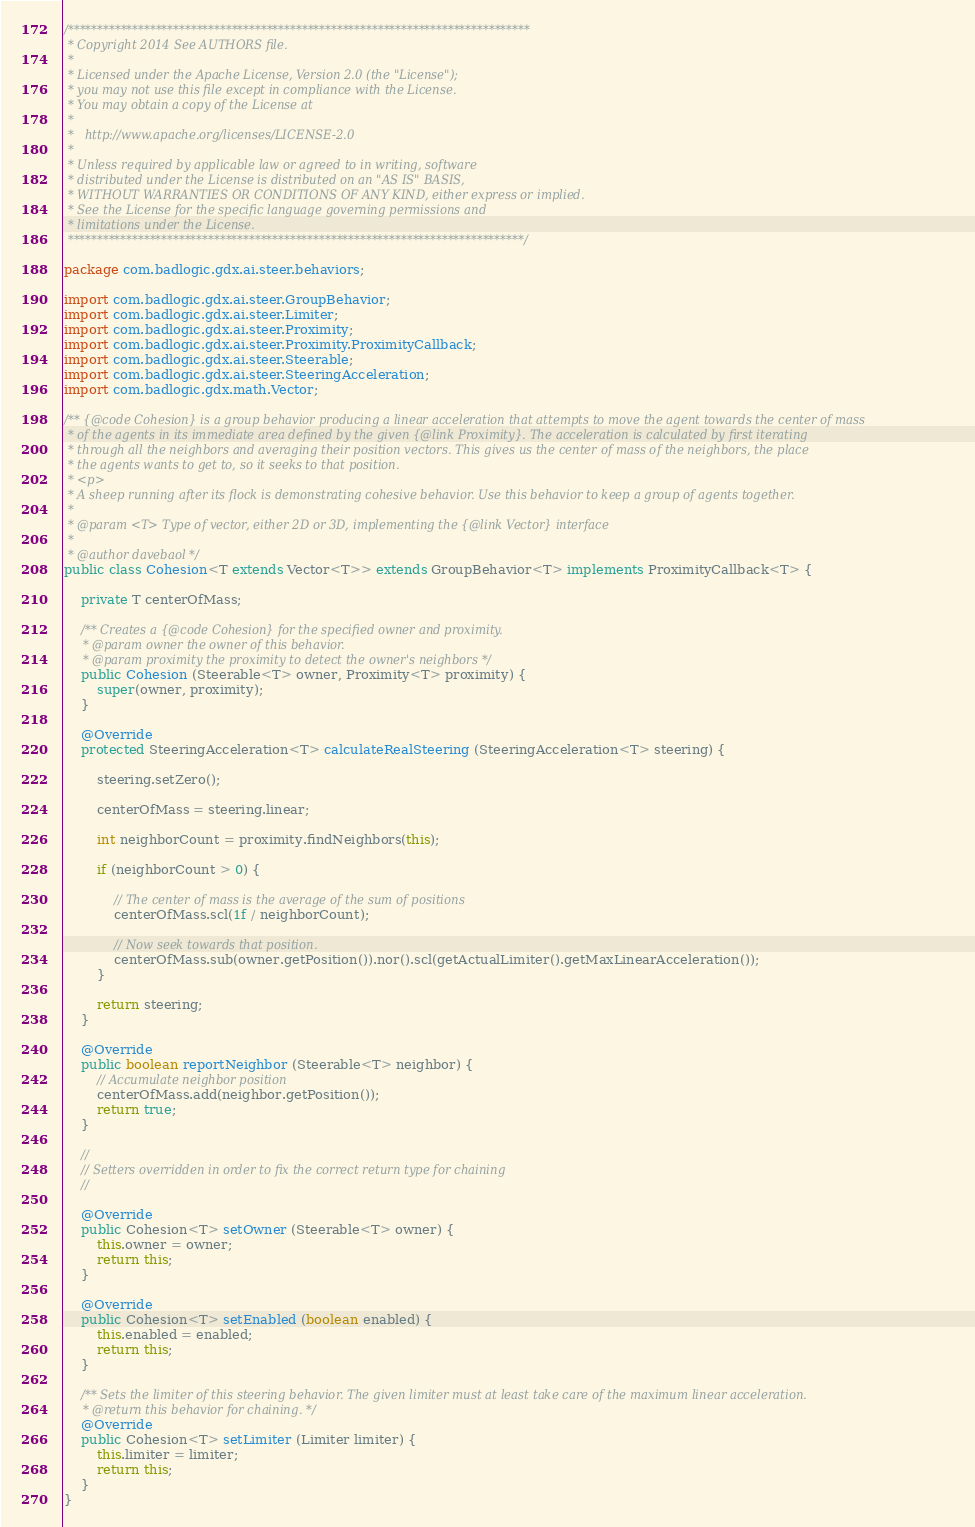Convert code to text. <code><loc_0><loc_0><loc_500><loc_500><_Java_>/*******************************************************************************
 * Copyright 2014 See AUTHORS file.
 * 
 * Licensed under the Apache License, Version 2.0 (the "License");
 * you may not use this file except in compliance with the License.
 * You may obtain a copy of the License at
 * 
 *   http://www.apache.org/licenses/LICENSE-2.0
 * 
 * Unless required by applicable law or agreed to in writing, software
 * distributed under the License is distributed on an "AS IS" BASIS,
 * WITHOUT WARRANTIES OR CONDITIONS OF ANY KIND, either express or implied.
 * See the License for the specific language governing permissions and
 * limitations under the License.
 ******************************************************************************/

package com.badlogic.gdx.ai.steer.behaviors;

import com.badlogic.gdx.ai.steer.GroupBehavior;
import com.badlogic.gdx.ai.steer.Limiter;
import com.badlogic.gdx.ai.steer.Proximity;
import com.badlogic.gdx.ai.steer.Proximity.ProximityCallback;
import com.badlogic.gdx.ai.steer.Steerable;
import com.badlogic.gdx.ai.steer.SteeringAcceleration;
import com.badlogic.gdx.math.Vector;

/** {@code Cohesion} is a group behavior producing a linear acceleration that attempts to move the agent towards the center of mass
 * of the agents in its immediate area defined by the given {@link Proximity}. The acceleration is calculated by first iterating
 * through all the neighbors and averaging their position vectors. This gives us the center of mass of the neighbors, the place
 * the agents wants to get to, so it seeks to that position.
 * <p>
 * A sheep running after its flock is demonstrating cohesive behavior. Use this behavior to keep a group of agents together.
 * 
 * @param <T> Type of vector, either 2D or 3D, implementing the {@link Vector} interface
 * 
 * @author davebaol */
public class Cohesion<T extends Vector<T>> extends GroupBehavior<T> implements ProximityCallback<T> {

	private T centerOfMass;

	/** Creates a {@code Cohesion} for the specified owner and proximity.
	 * @param owner the owner of this behavior.
	 * @param proximity the proximity to detect the owner's neighbors */
	public Cohesion (Steerable<T> owner, Proximity<T> proximity) {
		super(owner, proximity);
	}

	@Override
	protected SteeringAcceleration<T> calculateRealSteering (SteeringAcceleration<T> steering) {

		steering.setZero();

		centerOfMass = steering.linear;

		int neighborCount = proximity.findNeighbors(this);

		if (neighborCount > 0) {

			// The center of mass is the average of the sum of positions
			centerOfMass.scl(1f / neighborCount);

			// Now seek towards that position.
			centerOfMass.sub(owner.getPosition()).nor().scl(getActualLimiter().getMaxLinearAcceleration());
		}

		return steering;
	}

	@Override
	public boolean reportNeighbor (Steerable<T> neighbor) {
		// Accumulate neighbor position
		centerOfMass.add(neighbor.getPosition());
		return true;
	}

	//
	// Setters overridden in order to fix the correct return type for chaining
	//

	@Override
	public Cohesion<T> setOwner (Steerable<T> owner) {
		this.owner = owner;
		return this;
	}

	@Override
	public Cohesion<T> setEnabled (boolean enabled) {
		this.enabled = enabled;
		return this;
	}

	/** Sets the limiter of this steering behavior. The given limiter must at least take care of the maximum linear acceleration.
	 * @return this behavior for chaining. */
	@Override
	public Cohesion<T> setLimiter (Limiter limiter) {
		this.limiter = limiter;
		return this;
	}
}
</code> 